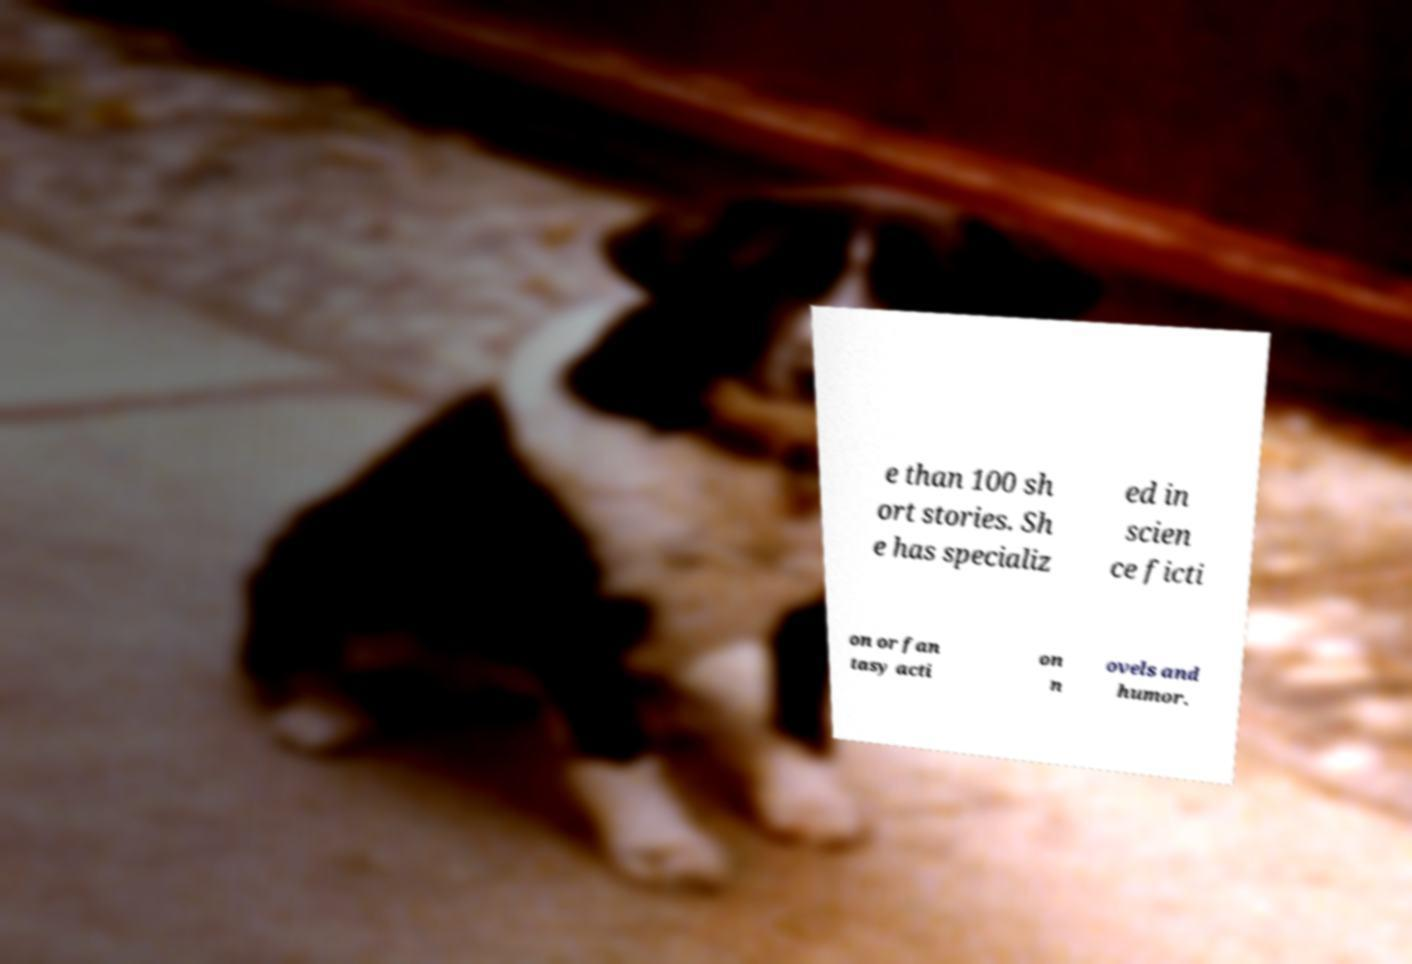Can you accurately transcribe the text from the provided image for me? e than 100 sh ort stories. Sh e has specializ ed in scien ce ficti on or fan tasy acti on n ovels and humor. 